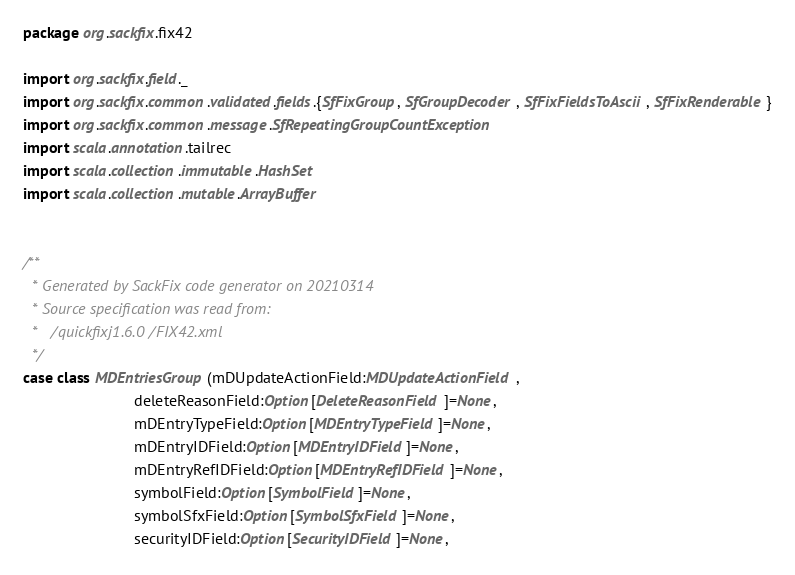Convert code to text. <code><loc_0><loc_0><loc_500><loc_500><_Scala_>package org.sackfix.fix42

import org.sackfix.field._
import org.sackfix.common.validated.fields.{SfFixGroup, SfGroupDecoder, SfFixFieldsToAscii, SfFixRenderable}
import org.sackfix.common.message.SfRepeatingGroupCountException
import scala.annotation.tailrec
import scala.collection.immutable.HashSet
import scala.collection.mutable.ArrayBuffer


/**
  * Generated by SackFix code generator on 20210314
  * Source specification was read from:
  *   /quickfixj1.6.0/FIX42.xml
  */
case class MDEntriesGroup(mDUpdateActionField:MDUpdateActionField,
                          deleteReasonField:Option[DeleteReasonField]=None,
                          mDEntryTypeField:Option[MDEntryTypeField]=None,
                          mDEntryIDField:Option[MDEntryIDField]=None,
                          mDEntryRefIDField:Option[MDEntryRefIDField]=None,
                          symbolField:Option[SymbolField]=None,
                          symbolSfxField:Option[SymbolSfxField]=None,
                          securityIDField:Option[SecurityIDField]=None,</code> 